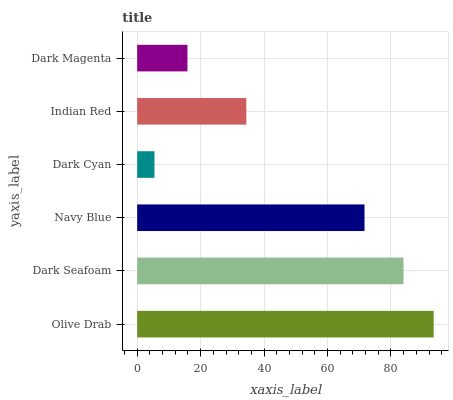Is Dark Cyan the minimum?
Answer yes or no. Yes. Is Olive Drab the maximum?
Answer yes or no. Yes. Is Dark Seafoam the minimum?
Answer yes or no. No. Is Dark Seafoam the maximum?
Answer yes or no. No. Is Olive Drab greater than Dark Seafoam?
Answer yes or no. Yes. Is Dark Seafoam less than Olive Drab?
Answer yes or no. Yes. Is Dark Seafoam greater than Olive Drab?
Answer yes or no. No. Is Olive Drab less than Dark Seafoam?
Answer yes or no. No. Is Navy Blue the high median?
Answer yes or no. Yes. Is Indian Red the low median?
Answer yes or no. Yes. Is Dark Cyan the high median?
Answer yes or no. No. Is Olive Drab the low median?
Answer yes or no. No. 